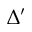<formula> <loc_0><loc_0><loc_500><loc_500>\Delta ^ { \prime }</formula> 